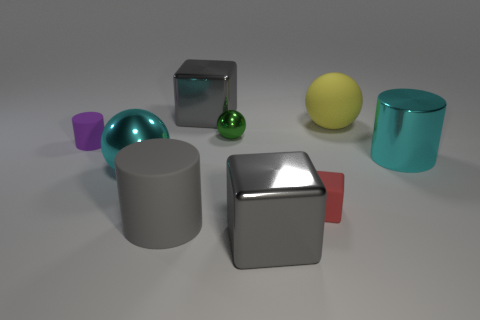Subtract all large spheres. How many spheres are left? 1 Add 1 cyan rubber cubes. How many objects exist? 10 Subtract all gray blocks. How many cyan balls are left? 1 Subtract all gray cubes. How many cubes are left? 1 Subtract 1 cylinders. How many cylinders are left? 2 Subtract all red blocks. Subtract all red balls. How many blocks are left? 2 Subtract all gray things. Subtract all small cylinders. How many objects are left? 5 Add 2 cyan metallic things. How many cyan metallic things are left? 4 Add 5 large metallic cubes. How many large metallic cubes exist? 7 Subtract 0 green blocks. How many objects are left? 9 